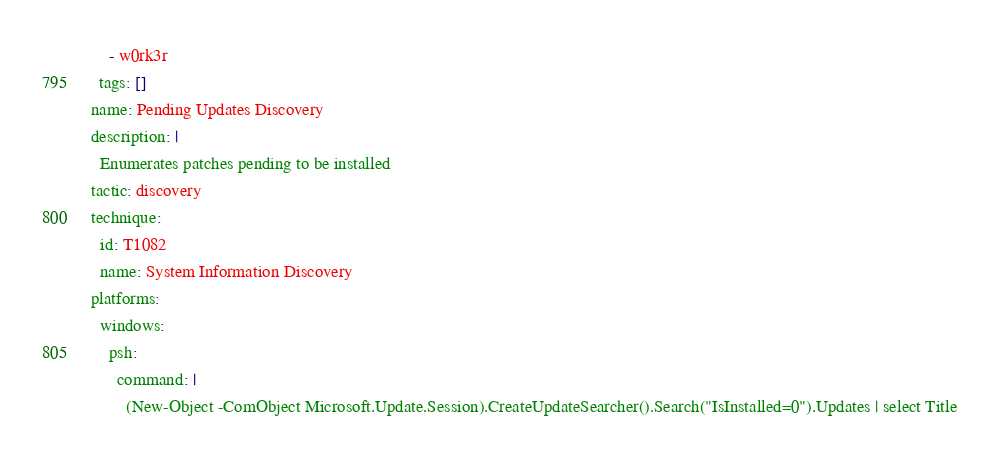Convert code to text. <code><loc_0><loc_0><loc_500><loc_500><_YAML_>    - w0rk3r
  tags: []
name: Pending Updates Discovery
description: |
  Enumerates patches pending to be installed
tactic: discovery
technique:
  id: T1082
  name: System Information Discovery
platforms:
  windows:
    psh:
      command: |
        (New-Object -ComObject Microsoft.Update.Session).CreateUpdateSearcher().Search("IsInstalled=0").Updates | select Title</code> 